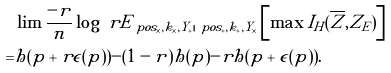Convert formula to latex. <formula><loc_0><loc_0><loc_500><loc_500>& \lim \frac { - r } { n } \log \ r E _ { \ p o s _ { \times } , k _ { \times } , Y _ { + } | \ p o s _ { + } , k _ { + } , Y _ { \times } } \left [ \max I _ { H } ( \overline { Z } , Z _ { E } ) \right ] \\ = & h ( p + r \epsilon ( p ) ) - ( 1 - r ) h ( p ) - r h ( p + \epsilon ( p ) ) .</formula> 